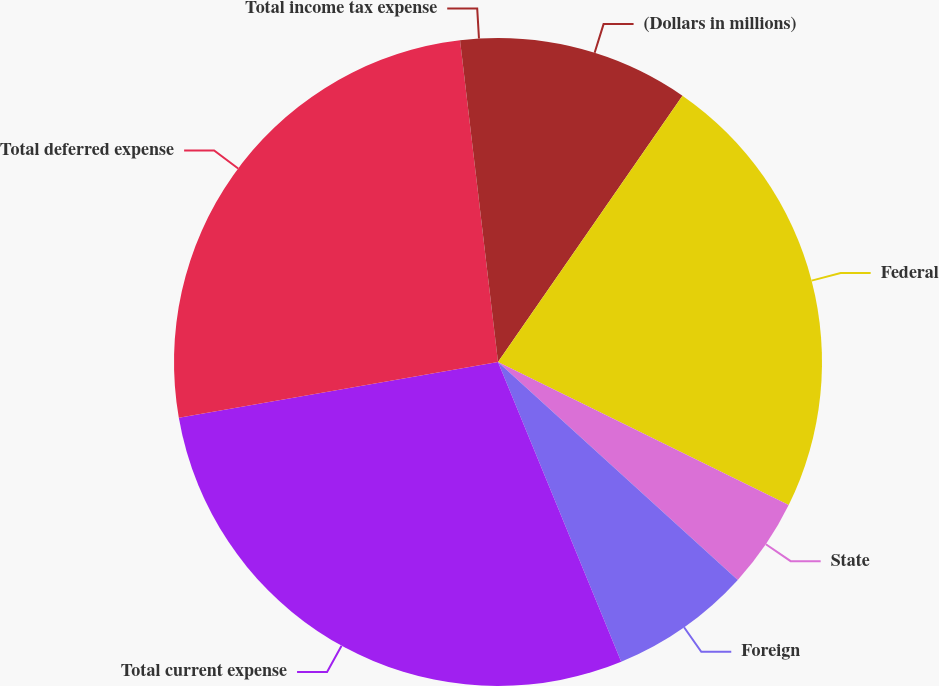Convert chart to OTSL. <chart><loc_0><loc_0><loc_500><loc_500><pie_chart><fcel>(Dollars in millions)<fcel>Federal<fcel>State<fcel>Foreign<fcel>Total current expense<fcel>Total deferred expense<fcel>Total income tax expense<nl><fcel>9.64%<fcel>22.64%<fcel>4.46%<fcel>7.05%<fcel>28.46%<fcel>25.88%<fcel>1.87%<nl></chart> 